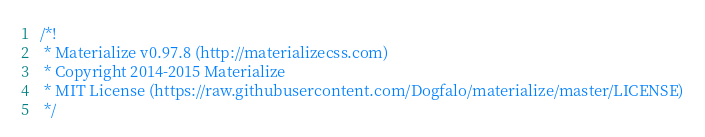<code> <loc_0><loc_0><loc_500><loc_500><_CSS_>/*!
 * Materialize v0.97.8 (http://materializecss.com)
 * Copyright 2014-2015 Materialize
 * MIT License (https://raw.githubusercontent.com/Dogfalo/materialize/master/LICENSE)
 */</code> 